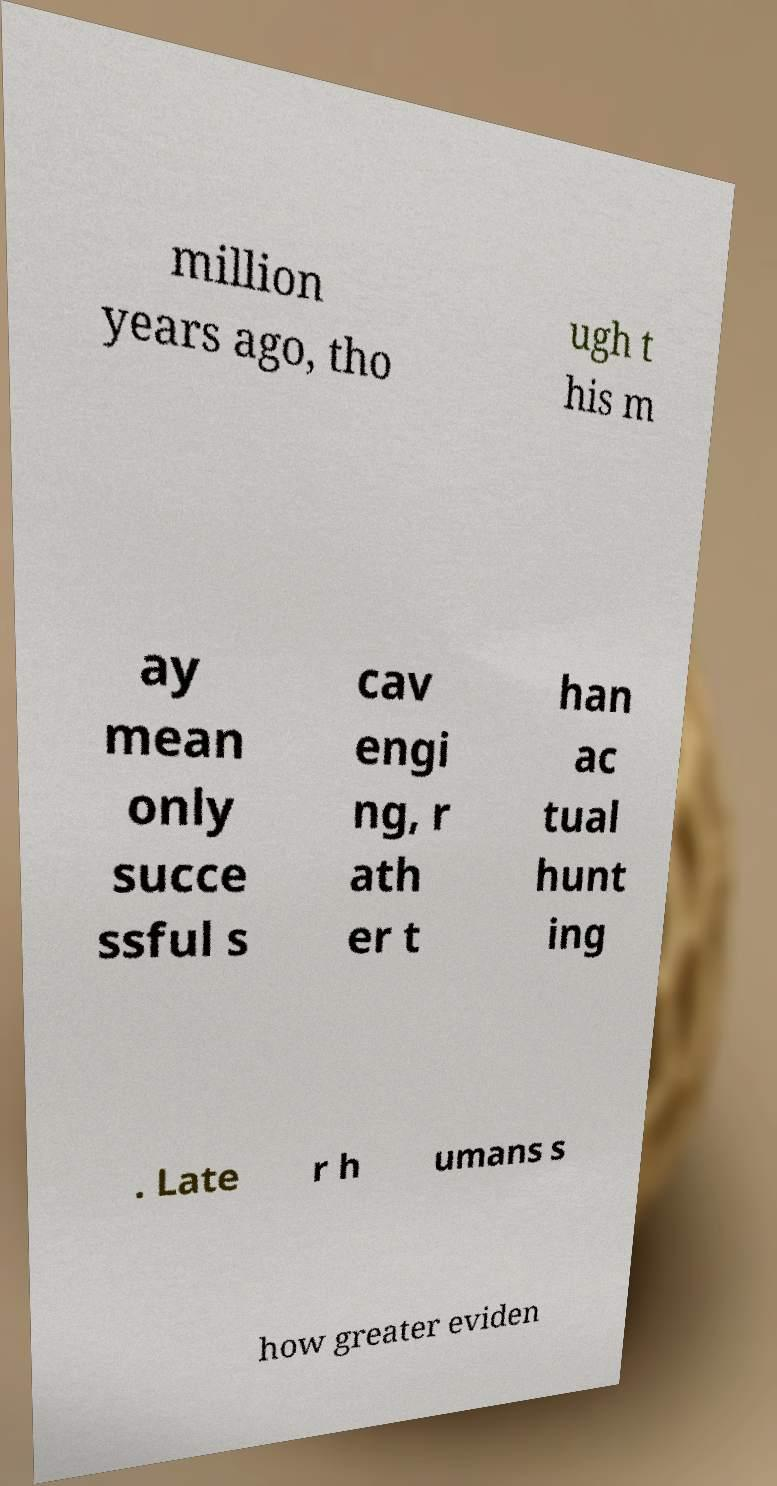Please read and relay the text visible in this image. What does it say? million years ago, tho ugh t his m ay mean only succe ssful s cav engi ng, r ath er t han ac tual hunt ing . Late r h umans s how greater eviden 